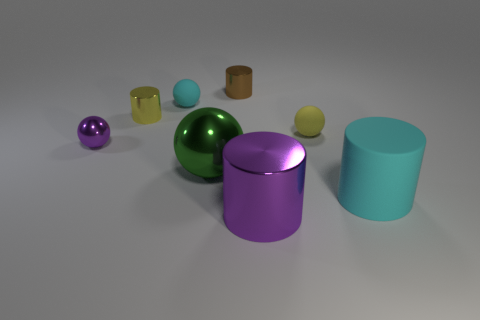Subtract all shiny cylinders. How many cylinders are left? 1 Subtract all purple spheres. How many spheres are left? 3 Add 1 big rubber things. How many objects exist? 9 Subtract 3 cylinders. How many cylinders are left? 1 Subtract 0 blue cylinders. How many objects are left? 8 Subtract all blue balls. Subtract all purple cylinders. How many balls are left? 4 Subtract all gray cylinders. How many yellow balls are left? 1 Subtract all yellow metallic cylinders. Subtract all big metal objects. How many objects are left? 5 Add 3 small brown shiny objects. How many small brown shiny objects are left? 4 Add 3 tiny metal objects. How many tiny metal objects exist? 6 